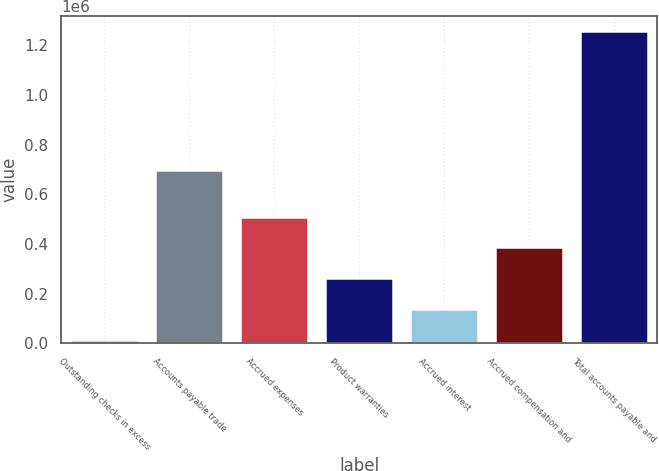Convert chart. <chart><loc_0><loc_0><loc_500><loc_500><bar_chart><fcel>Outstanding checks in excess<fcel>Accounts payable trade<fcel>Accrued expenses<fcel>Product warranties<fcel>Accrued interest<fcel>Accrued compensation and<fcel>Total accounts payable and<nl><fcel>14023<fcel>696974<fcel>510824<fcel>262423<fcel>138223<fcel>386624<fcel>1.25602e+06<nl></chart> 